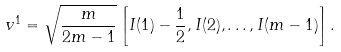Convert formula to latex. <formula><loc_0><loc_0><loc_500><loc_500>v ^ { 1 } = \sqrt { \frac { m } { 2 m - 1 } } \left [ I ( 1 ) - \frac { 1 } { 2 } , I ( 2 ) , \dots , I ( m - 1 ) \right ] .</formula> 